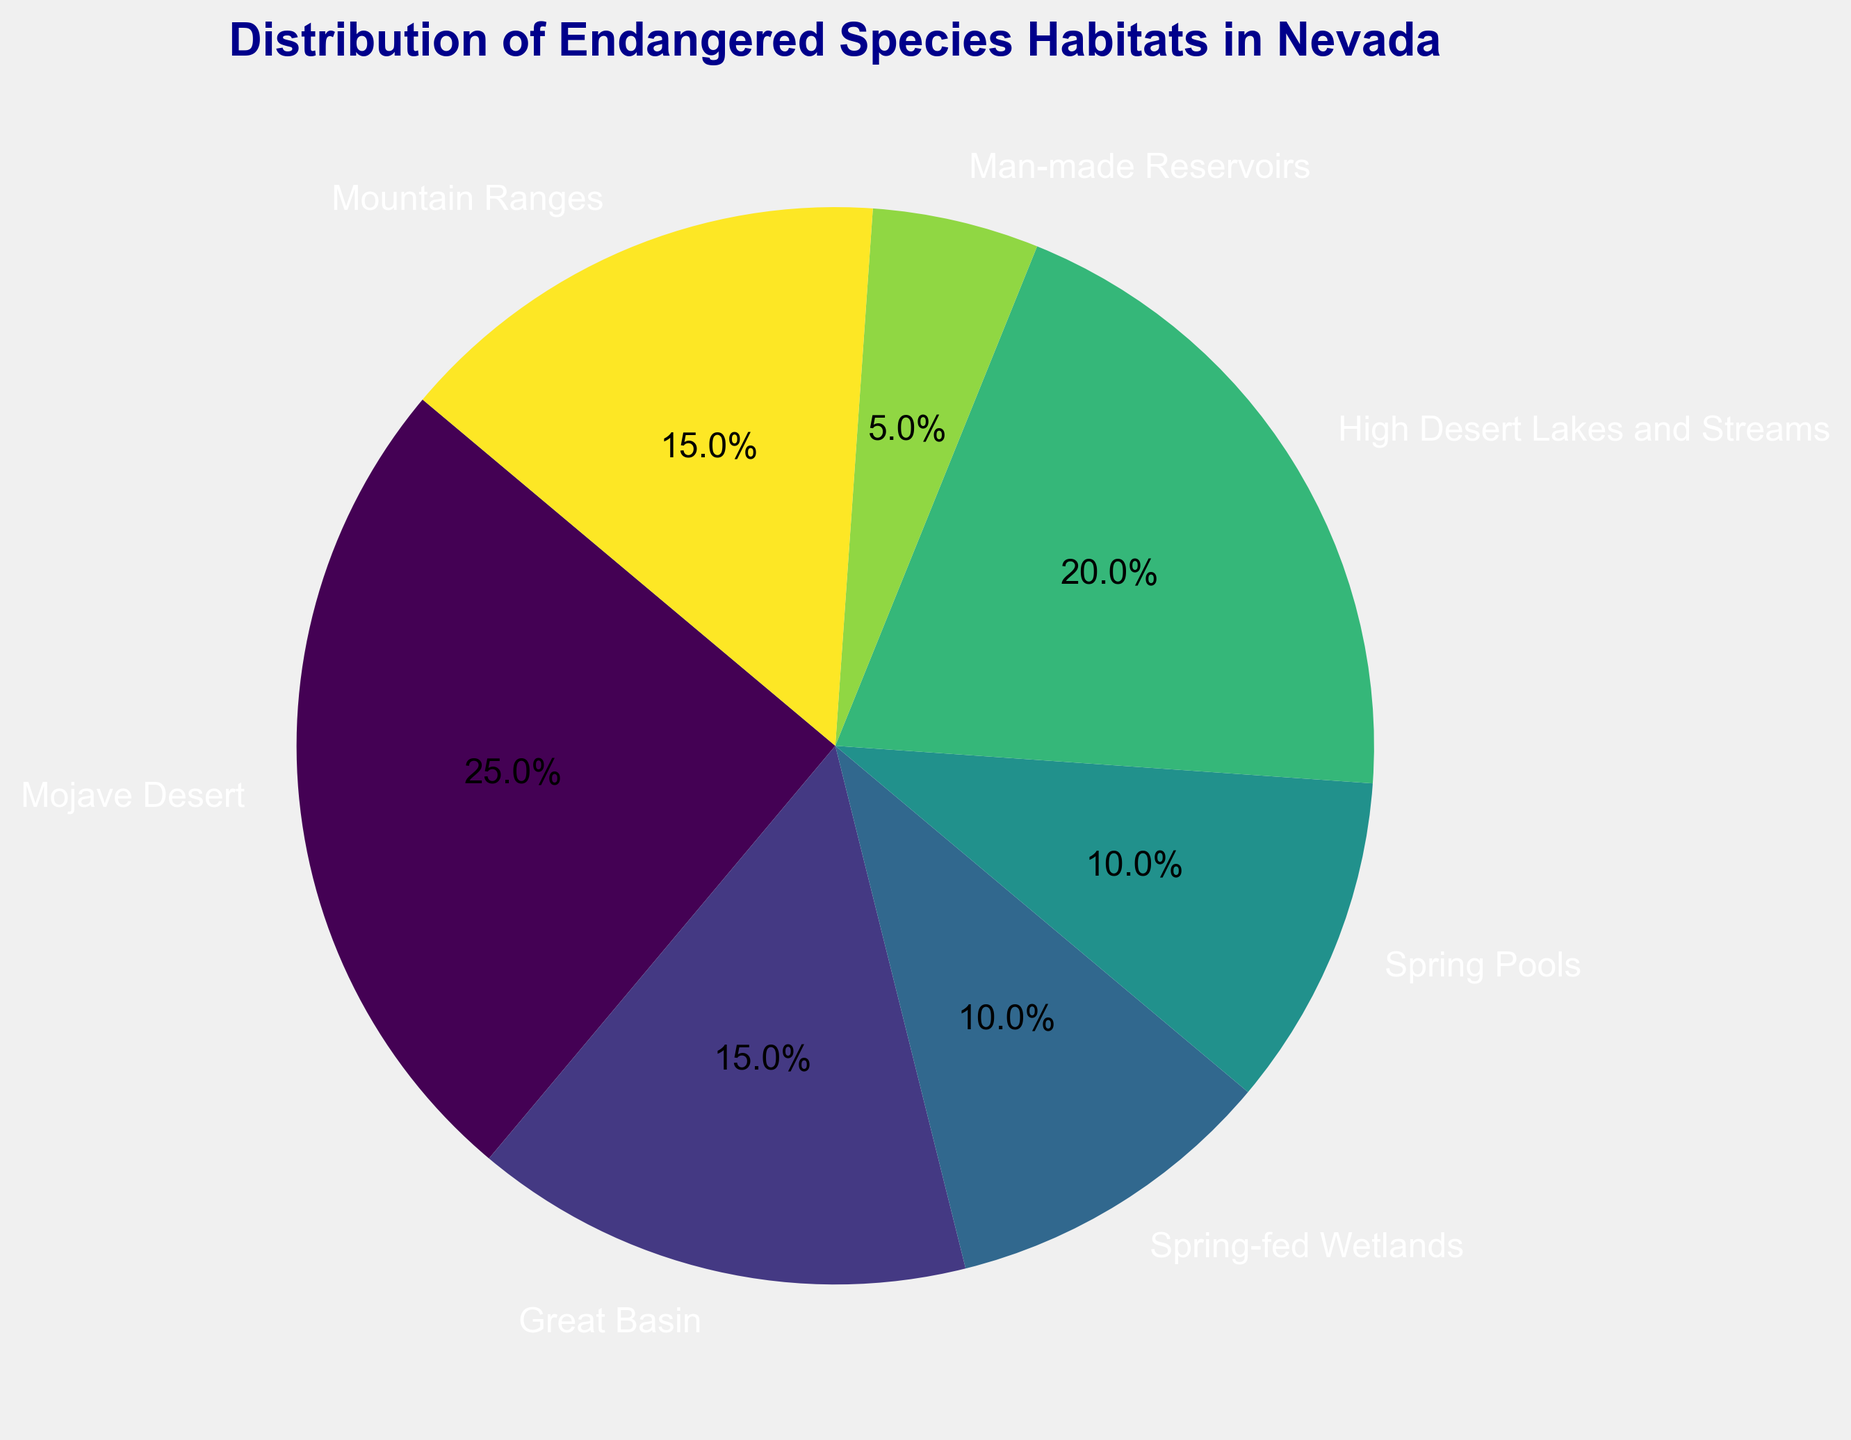Which habitat has the largest percentage of endangered species? The largest wedge in the pie chart represents the Mojave Desert, which is the habitat with the largest percentage of endangered species.
Answer: Mojave Desert How much more percentage does the Mojave Desert have compared to the Great Basin? The Mojave Desert has 25% and the Great Basin has 15%. The difference in percentage is calculated as 25% - 15% = 10%.
Answer: 10% What is the combined percentage of endangered species found in both Spring-fed Wetlands and Spring Pools? According to the chart, Spring-fed Wetlands have 10% and Spring Pools have 10%. The combined percentage is 10% + 10% = 20%.
Answer: 20% What is the total percentage of endangered species not living in Desert regions (Mojave Desert and High Desert Lakes and Streams)? The percentages outside of Desert regions are: Great Basin (15%), Spring-fed Wetlands (10%), Spring Pools (10%), Man-made Reservoirs (5%), and Mountain Ranges (15%). Summing them up: 15% + 10% + 10% + 5% + 15% = 55%.
Answer: 55% Is the percentage of Sierra Nevada Bighorn Sheep's habitat the same as any other habitat? Upon inspection, the percentage for the Great Basin and the Sierra Nevada Bighorn Sheep's habitat (Mountain Ranges) are both 15%.
Answer: Yes Which habitat is represented by the smallest wedge in the pie chart? The smallest wedge in the pie chart corresponds to Man-made Reservoirs, which has a percentage of 5%.
Answer: Man-made Reservoirs What percentage of endangered species live in habitats associated with water (Spring-fed Wetlands, Spring Pools, High Desert Lakes and Streams)? The relevant habitats are Spring-fed Wetlands (10%), Spring Pools (10%), and High Desert Lakes and Streams (20%). The total is 10% + 10% + 20% = 40%.
Answer: 40% If habitats were grouped by similar types, which grouped habitats would have the highest combined percentage: deserts (Mojave Desert, High Desert Lakes and Streams), or water-associated (Spring-fed Wetlands, Spring Pools, Man-made Reservoirs)? The deserts have Mojave Desert (25%) and High Desert Lakes and Streams (20%), combining to 25% + 20% = 45%. The water-associated habitats include Spring-fed Wetlands (10%), Spring Pools (10%), and Man-made Reservoirs (5%), combining to 10% + 10% + 5% = 25%. So, desert habitats have the highest combined percentage.
Answer: Deserts What's the percentage difference between the habitat with the highest percentage and the habitat with the lowest percentage? The habitat with the highest percentage is Mojave Desert (25%) and the one with the lowest percentage is Man-made Reservoirs (5%). The difference is 25% - 5% = 20%.
Answer: 20% 